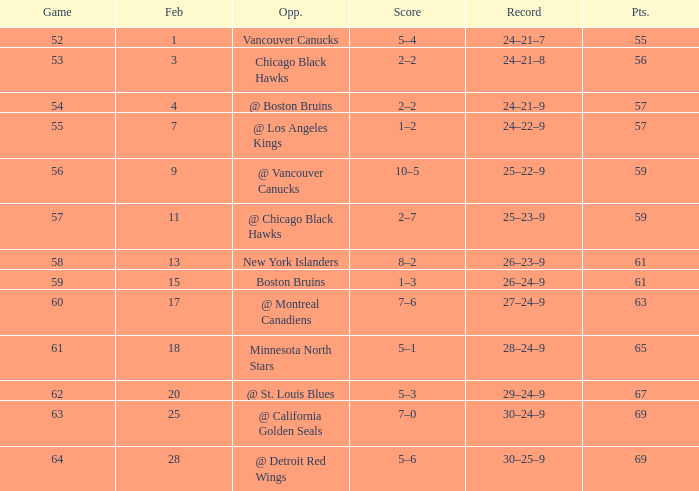Which opponent has a game larger than 61, february smaller than 28, and fewer points than 69? @ St. Louis Blues. 